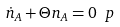Convert formula to latex. <formula><loc_0><loc_0><loc_500><loc_500>\dot { n } _ { A } + \Theta n _ { A } = 0 \ p</formula> 